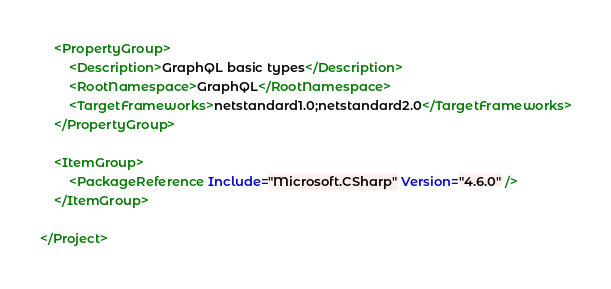Convert code to text. <code><loc_0><loc_0><loc_500><loc_500><_XML_>	<PropertyGroup>
		<Description>GraphQL basic types</Description>
		<RootNamespace>GraphQL</RootNamespace>
		<TargetFrameworks>netstandard1.0;netstandard2.0</TargetFrameworks>
	</PropertyGroup>

	<ItemGroup>
		<PackageReference Include="Microsoft.CSharp" Version="4.6.0" />
	</ItemGroup>

</Project>
</code> 